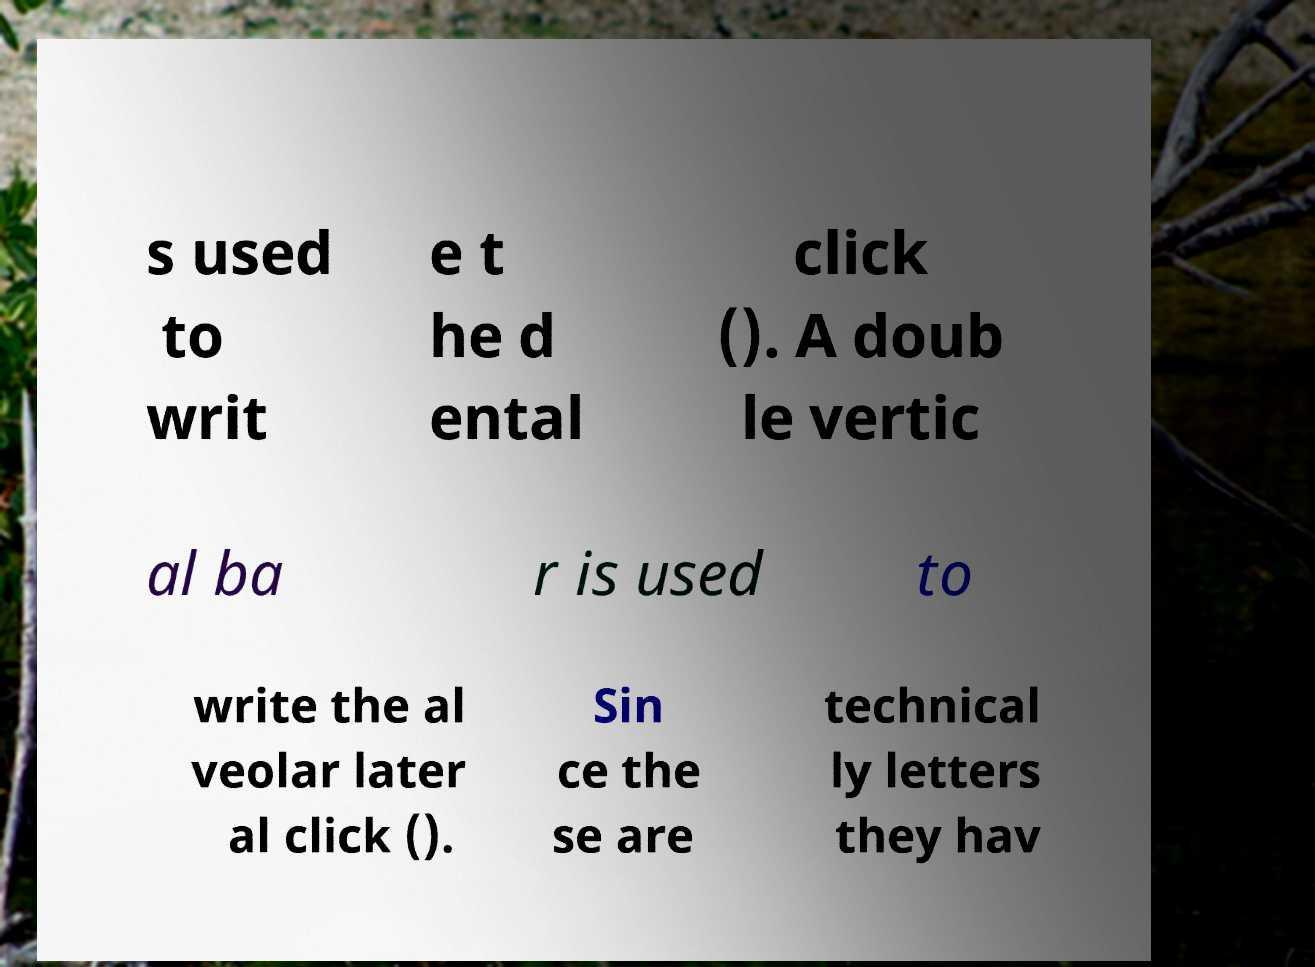Please read and relay the text visible in this image. What does it say? s used to writ e t he d ental click (). A doub le vertic al ba r is used to write the al veolar later al click (). Sin ce the se are technical ly letters they hav 